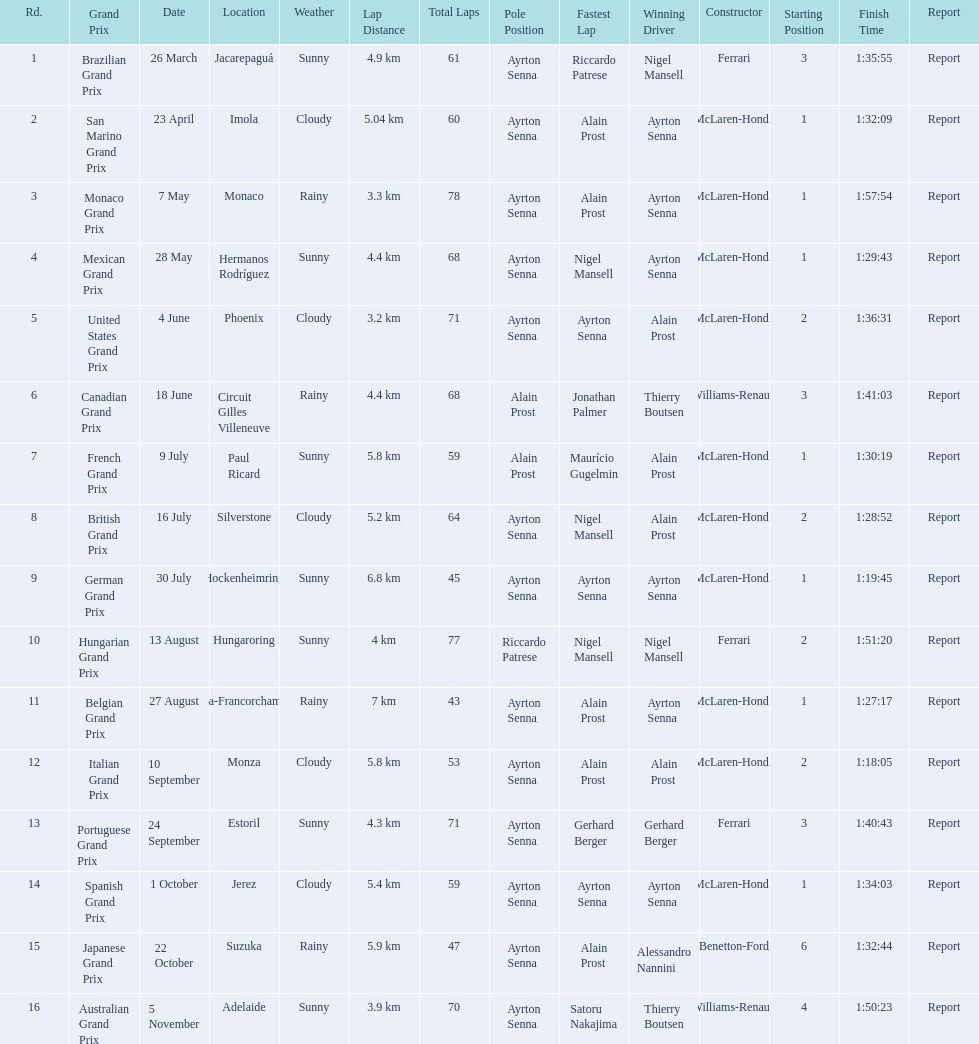What are all of the grand prix run in the 1989 formula one season? Brazilian Grand Prix, San Marino Grand Prix, Monaco Grand Prix, Mexican Grand Prix, United States Grand Prix, Canadian Grand Prix, French Grand Prix, British Grand Prix, German Grand Prix, Hungarian Grand Prix, Belgian Grand Prix, Italian Grand Prix, Portuguese Grand Prix, Spanish Grand Prix, Japanese Grand Prix, Australian Grand Prix. Of those 1989 formula one grand prix, which were run in october? Spanish Grand Prix, Japanese Grand Prix, Australian Grand Prix. Of those 1989 formula one grand prix run in october, which was the only one to be won by benetton-ford? Japanese Grand Prix. 